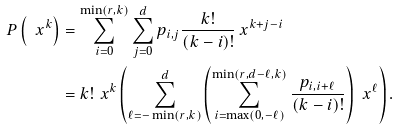<formula> <loc_0><loc_0><loc_500><loc_500>P \left ( \ x ^ { k } \right ) & = \sum _ { i = 0 } ^ { \min ( r , k ) } \sum _ { j = 0 } ^ { d } p _ { i , j } \frac { k ! } { ( k - i ) ! } \ x ^ { k + j - i } \\ & = k ! \, \ x ^ { k } \left ( \sum _ { \ell = - \min ( r , k ) } ^ { d } \left ( \sum _ { i = \max ( 0 , - \ell ) } ^ { \min ( r , d - \ell , k ) } \frac { p _ { i , i + \ell } } { ( k - i ) ! } \right ) \, \ x ^ { \ell } \right ) .</formula> 